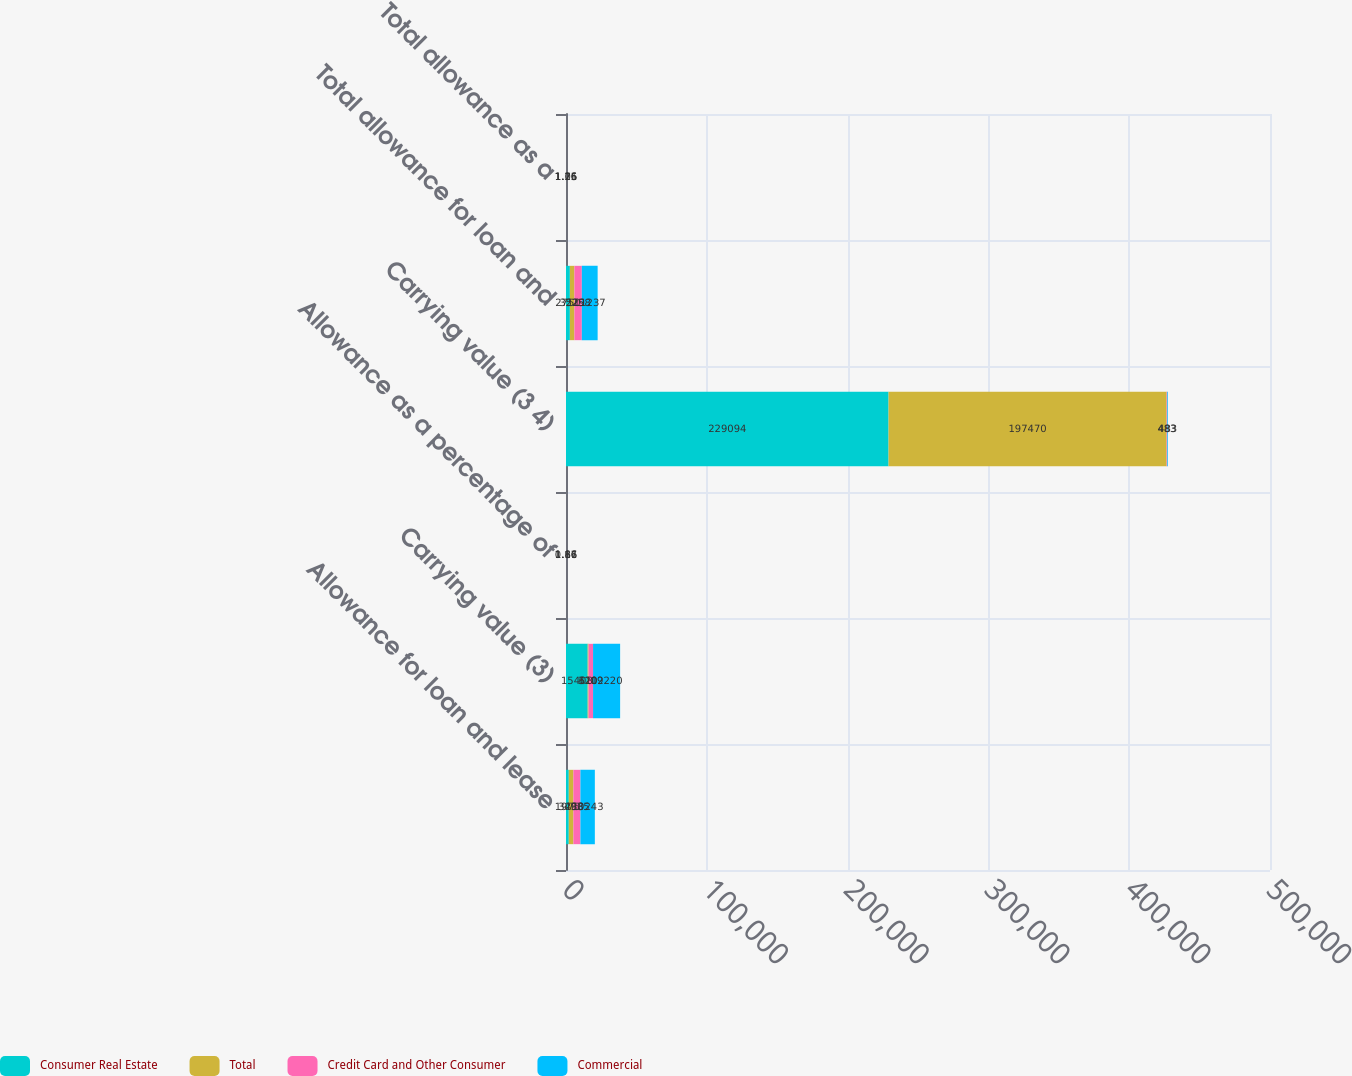<chart> <loc_0><loc_0><loc_500><loc_500><stacked_bar_chart><ecel><fcel>Allowance for loan and lease<fcel>Carrying value (3)<fcel>Allowance as a percentage of<fcel>Carrying value (3 4)<fcel>Total allowance for loan and<fcel>Total allowance as a<nl><fcel>Consumer Real Estate<fcel>1975<fcel>15408<fcel>0.86<fcel>229094<fcel>2750<fcel>1.06<nl><fcel>Total<fcel>3283<fcel>610<fcel>1.66<fcel>197470<fcel>3229<fcel>1.71<nl><fcel>Credit Card and Other Consumer<fcel>4985<fcel>3202<fcel>1.11<fcel>483<fcel>5258<fcel>1.16<nl><fcel>Commercial<fcel>10243<fcel>19220<fcel>1.17<fcel>483<fcel>11237<fcel>1.25<nl></chart> 